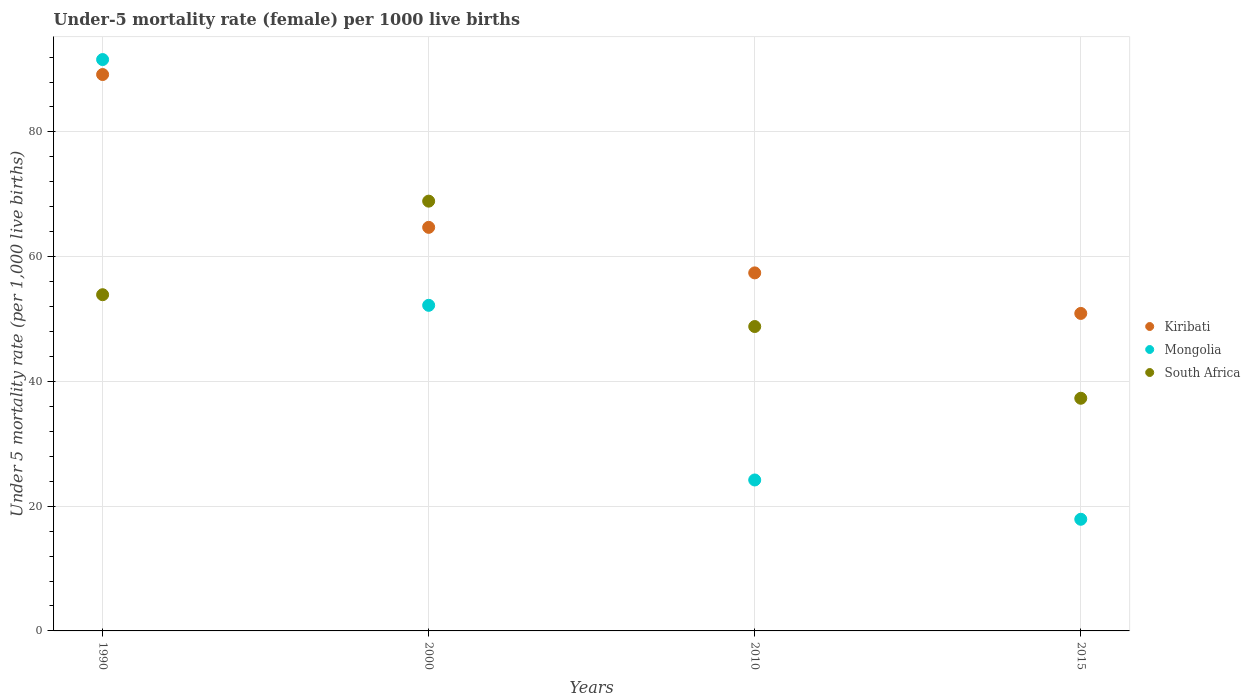Is the number of dotlines equal to the number of legend labels?
Offer a very short reply. Yes. What is the under-five mortality rate in Kiribati in 2015?
Provide a succinct answer. 50.9. Across all years, what is the maximum under-five mortality rate in Mongolia?
Ensure brevity in your answer.  91.6. Across all years, what is the minimum under-five mortality rate in Kiribati?
Your answer should be very brief. 50.9. In which year was the under-five mortality rate in Mongolia minimum?
Provide a succinct answer. 2015. What is the total under-five mortality rate in South Africa in the graph?
Your response must be concise. 208.9. What is the difference between the under-five mortality rate in Mongolia in 2000 and that in 2015?
Give a very brief answer. 34.3. What is the average under-five mortality rate in South Africa per year?
Your answer should be compact. 52.23. In the year 2010, what is the difference between the under-five mortality rate in Mongolia and under-five mortality rate in Kiribati?
Your answer should be compact. -33.2. What is the ratio of the under-five mortality rate in Kiribati in 1990 to that in 2015?
Your response must be concise. 1.75. Is the under-five mortality rate in Kiribati in 2010 less than that in 2015?
Give a very brief answer. No. What is the difference between the highest and the second highest under-five mortality rate in Kiribati?
Offer a very short reply. 24.5. What is the difference between the highest and the lowest under-five mortality rate in Mongolia?
Your answer should be compact. 73.7. Is it the case that in every year, the sum of the under-five mortality rate in South Africa and under-five mortality rate in Mongolia  is greater than the under-five mortality rate in Kiribati?
Ensure brevity in your answer.  Yes. Does the under-five mortality rate in Kiribati monotonically increase over the years?
Ensure brevity in your answer.  No. Is the under-five mortality rate in Kiribati strictly greater than the under-five mortality rate in Mongolia over the years?
Keep it short and to the point. No. Are the values on the major ticks of Y-axis written in scientific E-notation?
Provide a succinct answer. No. Does the graph contain any zero values?
Ensure brevity in your answer.  No. How many legend labels are there?
Provide a succinct answer. 3. How are the legend labels stacked?
Provide a succinct answer. Vertical. What is the title of the graph?
Give a very brief answer. Under-5 mortality rate (female) per 1000 live births. What is the label or title of the X-axis?
Keep it short and to the point. Years. What is the label or title of the Y-axis?
Keep it short and to the point. Under 5 mortality rate (per 1,0 live births). What is the Under 5 mortality rate (per 1,000 live births) of Kiribati in 1990?
Offer a terse response. 89.2. What is the Under 5 mortality rate (per 1,000 live births) in Mongolia in 1990?
Offer a terse response. 91.6. What is the Under 5 mortality rate (per 1,000 live births) of South Africa in 1990?
Your answer should be compact. 53.9. What is the Under 5 mortality rate (per 1,000 live births) of Kiribati in 2000?
Provide a succinct answer. 64.7. What is the Under 5 mortality rate (per 1,000 live births) of Mongolia in 2000?
Your answer should be very brief. 52.2. What is the Under 5 mortality rate (per 1,000 live births) in South Africa in 2000?
Provide a short and direct response. 68.9. What is the Under 5 mortality rate (per 1,000 live births) of Kiribati in 2010?
Your answer should be compact. 57.4. What is the Under 5 mortality rate (per 1,000 live births) in Mongolia in 2010?
Ensure brevity in your answer.  24.2. What is the Under 5 mortality rate (per 1,000 live births) of South Africa in 2010?
Keep it short and to the point. 48.8. What is the Under 5 mortality rate (per 1,000 live births) in Kiribati in 2015?
Your answer should be very brief. 50.9. What is the Under 5 mortality rate (per 1,000 live births) in South Africa in 2015?
Your answer should be very brief. 37.3. Across all years, what is the maximum Under 5 mortality rate (per 1,000 live births) of Kiribati?
Ensure brevity in your answer.  89.2. Across all years, what is the maximum Under 5 mortality rate (per 1,000 live births) in Mongolia?
Provide a short and direct response. 91.6. Across all years, what is the maximum Under 5 mortality rate (per 1,000 live births) in South Africa?
Ensure brevity in your answer.  68.9. Across all years, what is the minimum Under 5 mortality rate (per 1,000 live births) of Kiribati?
Your response must be concise. 50.9. Across all years, what is the minimum Under 5 mortality rate (per 1,000 live births) of South Africa?
Ensure brevity in your answer.  37.3. What is the total Under 5 mortality rate (per 1,000 live births) in Kiribati in the graph?
Your answer should be very brief. 262.2. What is the total Under 5 mortality rate (per 1,000 live births) in Mongolia in the graph?
Keep it short and to the point. 185.9. What is the total Under 5 mortality rate (per 1,000 live births) of South Africa in the graph?
Provide a succinct answer. 208.9. What is the difference between the Under 5 mortality rate (per 1,000 live births) of Mongolia in 1990 and that in 2000?
Make the answer very short. 39.4. What is the difference between the Under 5 mortality rate (per 1,000 live births) in South Africa in 1990 and that in 2000?
Ensure brevity in your answer.  -15. What is the difference between the Under 5 mortality rate (per 1,000 live births) in Kiribati in 1990 and that in 2010?
Make the answer very short. 31.8. What is the difference between the Under 5 mortality rate (per 1,000 live births) in Mongolia in 1990 and that in 2010?
Your response must be concise. 67.4. What is the difference between the Under 5 mortality rate (per 1,000 live births) in South Africa in 1990 and that in 2010?
Provide a succinct answer. 5.1. What is the difference between the Under 5 mortality rate (per 1,000 live births) of Kiribati in 1990 and that in 2015?
Your response must be concise. 38.3. What is the difference between the Under 5 mortality rate (per 1,000 live births) in Mongolia in 1990 and that in 2015?
Keep it short and to the point. 73.7. What is the difference between the Under 5 mortality rate (per 1,000 live births) of South Africa in 1990 and that in 2015?
Keep it short and to the point. 16.6. What is the difference between the Under 5 mortality rate (per 1,000 live births) of Kiribati in 2000 and that in 2010?
Your response must be concise. 7.3. What is the difference between the Under 5 mortality rate (per 1,000 live births) of South Africa in 2000 and that in 2010?
Offer a terse response. 20.1. What is the difference between the Under 5 mortality rate (per 1,000 live births) in Mongolia in 2000 and that in 2015?
Give a very brief answer. 34.3. What is the difference between the Under 5 mortality rate (per 1,000 live births) of South Africa in 2000 and that in 2015?
Give a very brief answer. 31.6. What is the difference between the Under 5 mortality rate (per 1,000 live births) of Mongolia in 2010 and that in 2015?
Your response must be concise. 6.3. What is the difference between the Under 5 mortality rate (per 1,000 live births) of Kiribati in 1990 and the Under 5 mortality rate (per 1,000 live births) of Mongolia in 2000?
Your response must be concise. 37. What is the difference between the Under 5 mortality rate (per 1,000 live births) in Kiribati in 1990 and the Under 5 mortality rate (per 1,000 live births) in South Africa in 2000?
Offer a terse response. 20.3. What is the difference between the Under 5 mortality rate (per 1,000 live births) of Mongolia in 1990 and the Under 5 mortality rate (per 1,000 live births) of South Africa in 2000?
Provide a short and direct response. 22.7. What is the difference between the Under 5 mortality rate (per 1,000 live births) of Kiribati in 1990 and the Under 5 mortality rate (per 1,000 live births) of South Africa in 2010?
Your answer should be compact. 40.4. What is the difference between the Under 5 mortality rate (per 1,000 live births) of Mongolia in 1990 and the Under 5 mortality rate (per 1,000 live births) of South Africa in 2010?
Provide a short and direct response. 42.8. What is the difference between the Under 5 mortality rate (per 1,000 live births) of Kiribati in 1990 and the Under 5 mortality rate (per 1,000 live births) of Mongolia in 2015?
Provide a succinct answer. 71.3. What is the difference between the Under 5 mortality rate (per 1,000 live births) of Kiribati in 1990 and the Under 5 mortality rate (per 1,000 live births) of South Africa in 2015?
Your answer should be compact. 51.9. What is the difference between the Under 5 mortality rate (per 1,000 live births) of Mongolia in 1990 and the Under 5 mortality rate (per 1,000 live births) of South Africa in 2015?
Your answer should be compact. 54.3. What is the difference between the Under 5 mortality rate (per 1,000 live births) of Kiribati in 2000 and the Under 5 mortality rate (per 1,000 live births) of Mongolia in 2010?
Offer a terse response. 40.5. What is the difference between the Under 5 mortality rate (per 1,000 live births) of Kiribati in 2000 and the Under 5 mortality rate (per 1,000 live births) of South Africa in 2010?
Ensure brevity in your answer.  15.9. What is the difference between the Under 5 mortality rate (per 1,000 live births) in Kiribati in 2000 and the Under 5 mortality rate (per 1,000 live births) in Mongolia in 2015?
Provide a succinct answer. 46.8. What is the difference between the Under 5 mortality rate (per 1,000 live births) of Kiribati in 2000 and the Under 5 mortality rate (per 1,000 live births) of South Africa in 2015?
Keep it short and to the point. 27.4. What is the difference between the Under 5 mortality rate (per 1,000 live births) in Mongolia in 2000 and the Under 5 mortality rate (per 1,000 live births) in South Africa in 2015?
Provide a succinct answer. 14.9. What is the difference between the Under 5 mortality rate (per 1,000 live births) in Kiribati in 2010 and the Under 5 mortality rate (per 1,000 live births) in Mongolia in 2015?
Your answer should be compact. 39.5. What is the difference between the Under 5 mortality rate (per 1,000 live births) of Kiribati in 2010 and the Under 5 mortality rate (per 1,000 live births) of South Africa in 2015?
Ensure brevity in your answer.  20.1. What is the difference between the Under 5 mortality rate (per 1,000 live births) of Mongolia in 2010 and the Under 5 mortality rate (per 1,000 live births) of South Africa in 2015?
Your response must be concise. -13.1. What is the average Under 5 mortality rate (per 1,000 live births) in Kiribati per year?
Offer a very short reply. 65.55. What is the average Under 5 mortality rate (per 1,000 live births) of Mongolia per year?
Keep it short and to the point. 46.48. What is the average Under 5 mortality rate (per 1,000 live births) in South Africa per year?
Give a very brief answer. 52.23. In the year 1990, what is the difference between the Under 5 mortality rate (per 1,000 live births) of Kiribati and Under 5 mortality rate (per 1,000 live births) of Mongolia?
Provide a succinct answer. -2.4. In the year 1990, what is the difference between the Under 5 mortality rate (per 1,000 live births) in Kiribati and Under 5 mortality rate (per 1,000 live births) in South Africa?
Ensure brevity in your answer.  35.3. In the year 1990, what is the difference between the Under 5 mortality rate (per 1,000 live births) of Mongolia and Under 5 mortality rate (per 1,000 live births) of South Africa?
Make the answer very short. 37.7. In the year 2000, what is the difference between the Under 5 mortality rate (per 1,000 live births) of Kiribati and Under 5 mortality rate (per 1,000 live births) of Mongolia?
Ensure brevity in your answer.  12.5. In the year 2000, what is the difference between the Under 5 mortality rate (per 1,000 live births) in Mongolia and Under 5 mortality rate (per 1,000 live births) in South Africa?
Your answer should be compact. -16.7. In the year 2010, what is the difference between the Under 5 mortality rate (per 1,000 live births) of Kiribati and Under 5 mortality rate (per 1,000 live births) of Mongolia?
Ensure brevity in your answer.  33.2. In the year 2010, what is the difference between the Under 5 mortality rate (per 1,000 live births) of Mongolia and Under 5 mortality rate (per 1,000 live births) of South Africa?
Provide a short and direct response. -24.6. In the year 2015, what is the difference between the Under 5 mortality rate (per 1,000 live births) in Kiribati and Under 5 mortality rate (per 1,000 live births) in South Africa?
Your answer should be compact. 13.6. In the year 2015, what is the difference between the Under 5 mortality rate (per 1,000 live births) of Mongolia and Under 5 mortality rate (per 1,000 live births) of South Africa?
Keep it short and to the point. -19.4. What is the ratio of the Under 5 mortality rate (per 1,000 live births) in Kiribati in 1990 to that in 2000?
Provide a succinct answer. 1.38. What is the ratio of the Under 5 mortality rate (per 1,000 live births) of Mongolia in 1990 to that in 2000?
Provide a short and direct response. 1.75. What is the ratio of the Under 5 mortality rate (per 1,000 live births) in South Africa in 1990 to that in 2000?
Offer a very short reply. 0.78. What is the ratio of the Under 5 mortality rate (per 1,000 live births) in Kiribati in 1990 to that in 2010?
Provide a succinct answer. 1.55. What is the ratio of the Under 5 mortality rate (per 1,000 live births) of Mongolia in 1990 to that in 2010?
Provide a short and direct response. 3.79. What is the ratio of the Under 5 mortality rate (per 1,000 live births) in South Africa in 1990 to that in 2010?
Provide a succinct answer. 1.1. What is the ratio of the Under 5 mortality rate (per 1,000 live births) of Kiribati in 1990 to that in 2015?
Offer a terse response. 1.75. What is the ratio of the Under 5 mortality rate (per 1,000 live births) of Mongolia in 1990 to that in 2015?
Offer a terse response. 5.12. What is the ratio of the Under 5 mortality rate (per 1,000 live births) of South Africa in 1990 to that in 2015?
Offer a terse response. 1.45. What is the ratio of the Under 5 mortality rate (per 1,000 live births) in Kiribati in 2000 to that in 2010?
Your response must be concise. 1.13. What is the ratio of the Under 5 mortality rate (per 1,000 live births) of Mongolia in 2000 to that in 2010?
Ensure brevity in your answer.  2.16. What is the ratio of the Under 5 mortality rate (per 1,000 live births) of South Africa in 2000 to that in 2010?
Offer a terse response. 1.41. What is the ratio of the Under 5 mortality rate (per 1,000 live births) in Kiribati in 2000 to that in 2015?
Provide a succinct answer. 1.27. What is the ratio of the Under 5 mortality rate (per 1,000 live births) of Mongolia in 2000 to that in 2015?
Give a very brief answer. 2.92. What is the ratio of the Under 5 mortality rate (per 1,000 live births) in South Africa in 2000 to that in 2015?
Your answer should be compact. 1.85. What is the ratio of the Under 5 mortality rate (per 1,000 live births) of Kiribati in 2010 to that in 2015?
Offer a terse response. 1.13. What is the ratio of the Under 5 mortality rate (per 1,000 live births) of Mongolia in 2010 to that in 2015?
Offer a terse response. 1.35. What is the ratio of the Under 5 mortality rate (per 1,000 live births) in South Africa in 2010 to that in 2015?
Provide a short and direct response. 1.31. What is the difference between the highest and the second highest Under 5 mortality rate (per 1,000 live births) of Mongolia?
Give a very brief answer. 39.4. What is the difference between the highest and the second highest Under 5 mortality rate (per 1,000 live births) of South Africa?
Your answer should be very brief. 15. What is the difference between the highest and the lowest Under 5 mortality rate (per 1,000 live births) in Kiribati?
Ensure brevity in your answer.  38.3. What is the difference between the highest and the lowest Under 5 mortality rate (per 1,000 live births) in Mongolia?
Make the answer very short. 73.7. What is the difference between the highest and the lowest Under 5 mortality rate (per 1,000 live births) in South Africa?
Make the answer very short. 31.6. 